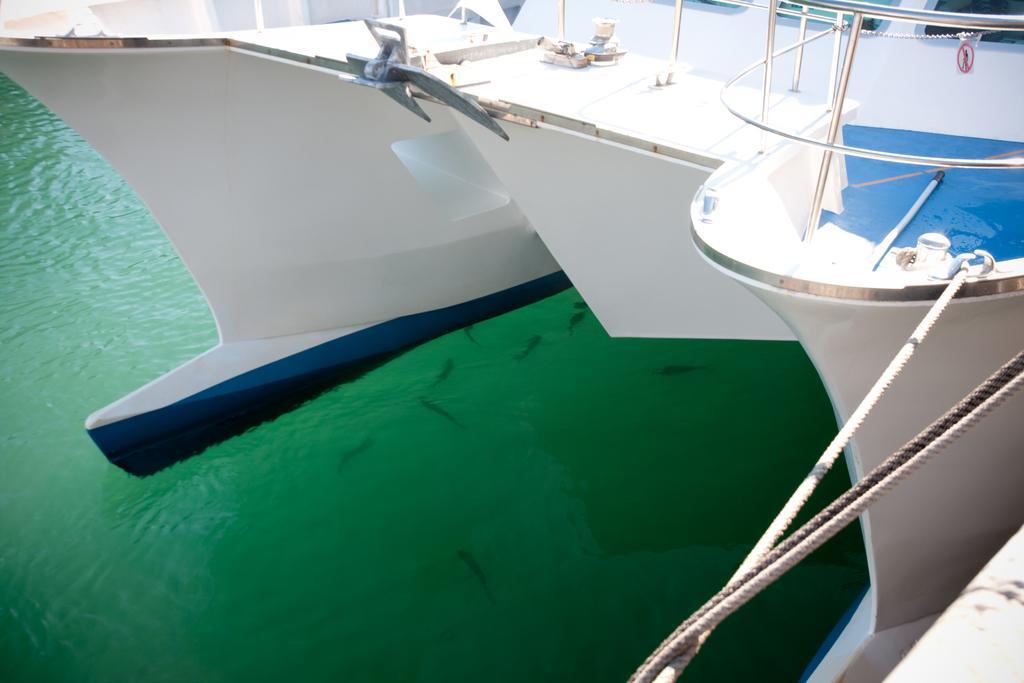Can you describe this image briefly? In front of the image there are ropes tied to the ship. There are fishes in the water. 